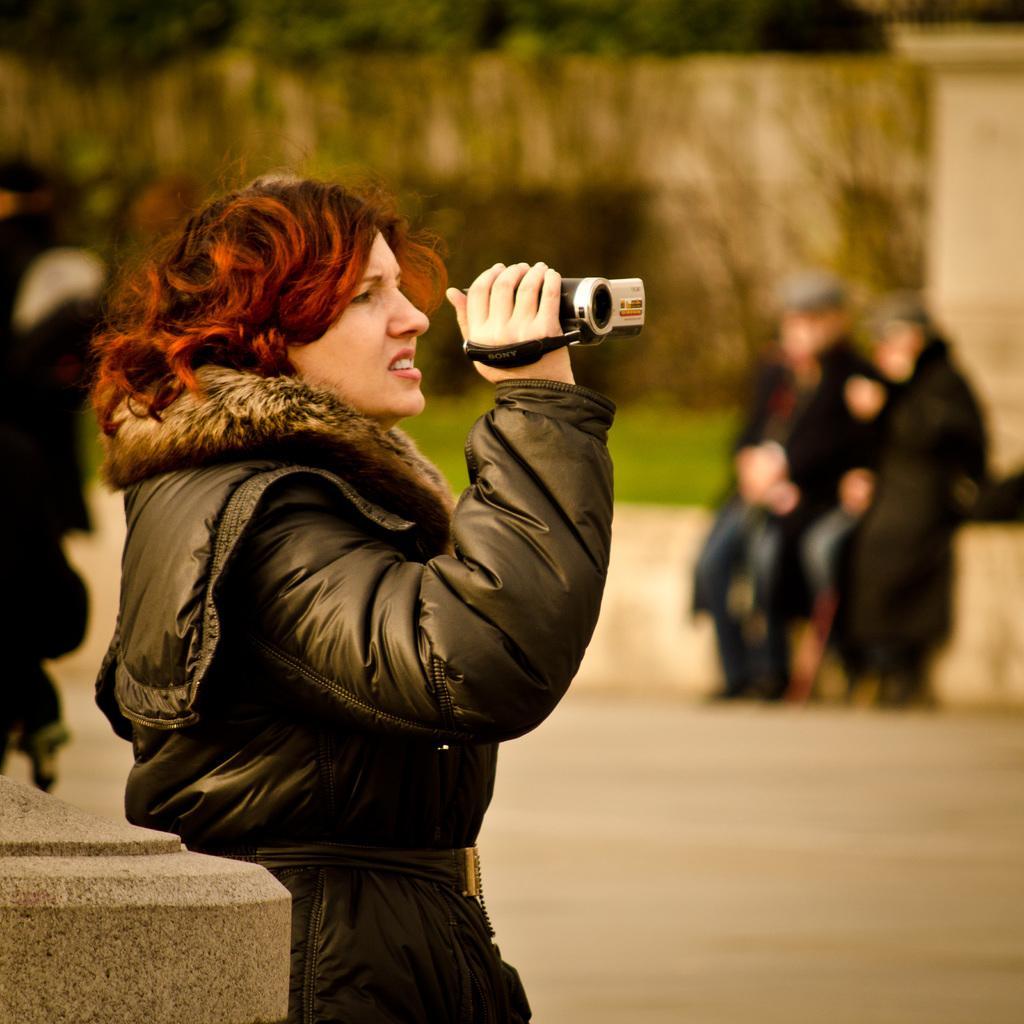Could you give a brief overview of what you see in this image? In this image we can see a woman holding a camera and behind her we can see trees, grass and people. 